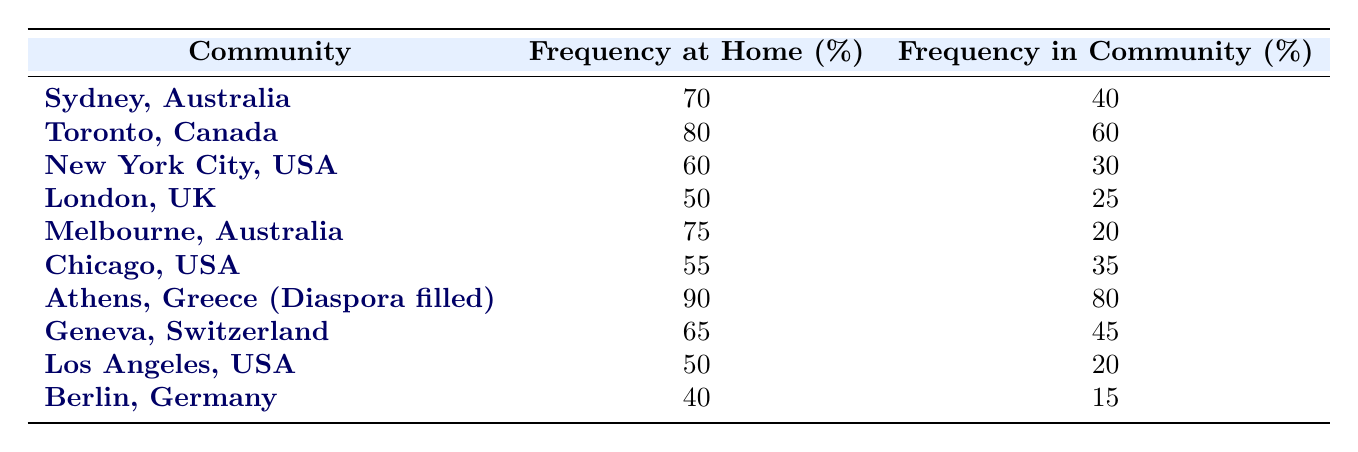What community has the highest frequency of Greek language use at home? By looking at the "Frequency at Home" column, "Athens, Greece (Diaspora filled)" has the highest percentage, which is 90.
Answer: 90 What is the frequency of Greek language use in New York City, USA? From the table, the "Frequency in Community" for New York City, USA, is 30.
Answer: 30 Which community has the lowest frequency of Greek language use in the community? Checking the "Frequency in Community" values, Berlin, Germany has the lowest percentage, which is 15.
Answer: 15 What is the average frequency of Greek language use at home across all communities listed? Summing the "Frequency at Home" values (70 + 80 + 60 + 50 + 75 + 55 + 90 + 65 + 50 + 40 = 700) and dividing by the number of communities (10), we get 700 / 10 = 70.
Answer: 70 Is the frequency of Greek language use at home in Sydney higher than that in Melbourne? In Sydney, the frequency at home is 70, while in Melbourne, it is 75. Since 70 is less than 75, the answer is no.
Answer: No What is the difference between the frequency of Greek language use at home in Toronto and in community use in London? The frequency at home in Toronto is 80, and the frequency in the community in London is 25. The difference is calculated as 80 - 25 = 55.
Answer: 55 Which community has a higher frequency of Greek language use at home, Athens or Chicago? The frequency at home in Athens is 90, and in Chicago, it is 55. Since 90 is greater than 55, Athens has a higher frequency.
Answer: Athens How much higher is the frequency of Greek language use in the community in Toronto compared to that in Melbourne? The frequency in Toronto is 60, and in Melbourne, it is 20. The difference is 60 - 20 = 40.
Answer: 40 Are there any communities where the frequency of Greek language use at home is less than the frequency of use in the community? Reviewing the values, only Berlin and Los Angeles show that at home percentages (40, 50) are less than community percentages (15, 20). Thus, the answer is yes.
Answer: Yes 